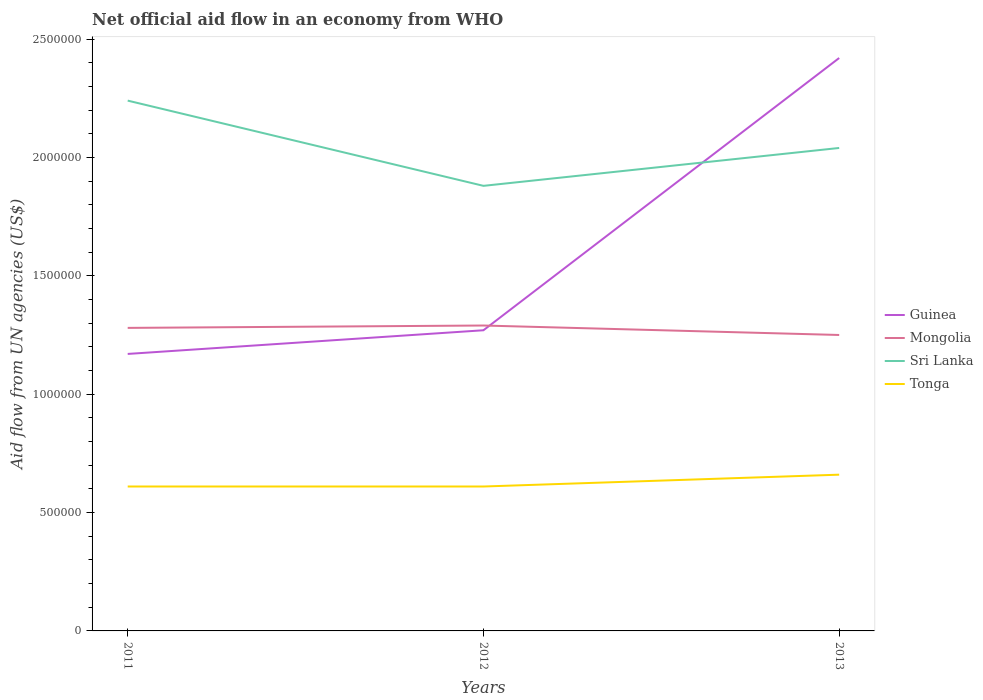How many different coloured lines are there?
Your answer should be very brief. 4. Does the line corresponding to Tonga intersect with the line corresponding to Guinea?
Give a very brief answer. No. Is the number of lines equal to the number of legend labels?
Your answer should be very brief. Yes. Across all years, what is the maximum net official aid flow in Sri Lanka?
Your answer should be compact. 1.88e+06. In which year was the net official aid flow in Guinea maximum?
Ensure brevity in your answer.  2011. What is the total net official aid flow in Sri Lanka in the graph?
Your answer should be very brief. 2.00e+05. What is the difference between the highest and the lowest net official aid flow in Mongolia?
Keep it short and to the point. 2. Is the net official aid flow in Mongolia strictly greater than the net official aid flow in Tonga over the years?
Provide a succinct answer. No. How many lines are there?
Ensure brevity in your answer.  4. How are the legend labels stacked?
Your answer should be compact. Vertical. What is the title of the graph?
Keep it short and to the point. Net official aid flow in an economy from WHO. What is the label or title of the X-axis?
Your answer should be very brief. Years. What is the label or title of the Y-axis?
Provide a short and direct response. Aid flow from UN agencies (US$). What is the Aid flow from UN agencies (US$) of Guinea in 2011?
Offer a very short reply. 1.17e+06. What is the Aid flow from UN agencies (US$) in Mongolia in 2011?
Offer a very short reply. 1.28e+06. What is the Aid flow from UN agencies (US$) of Sri Lanka in 2011?
Ensure brevity in your answer.  2.24e+06. What is the Aid flow from UN agencies (US$) of Tonga in 2011?
Provide a short and direct response. 6.10e+05. What is the Aid flow from UN agencies (US$) of Guinea in 2012?
Offer a very short reply. 1.27e+06. What is the Aid flow from UN agencies (US$) in Mongolia in 2012?
Your answer should be very brief. 1.29e+06. What is the Aid flow from UN agencies (US$) in Sri Lanka in 2012?
Your answer should be very brief. 1.88e+06. What is the Aid flow from UN agencies (US$) of Tonga in 2012?
Provide a succinct answer. 6.10e+05. What is the Aid flow from UN agencies (US$) of Guinea in 2013?
Your answer should be compact. 2.42e+06. What is the Aid flow from UN agencies (US$) of Mongolia in 2013?
Give a very brief answer. 1.25e+06. What is the Aid flow from UN agencies (US$) of Sri Lanka in 2013?
Ensure brevity in your answer.  2.04e+06. Across all years, what is the maximum Aid flow from UN agencies (US$) of Guinea?
Your answer should be compact. 2.42e+06. Across all years, what is the maximum Aid flow from UN agencies (US$) in Mongolia?
Offer a very short reply. 1.29e+06. Across all years, what is the maximum Aid flow from UN agencies (US$) in Sri Lanka?
Ensure brevity in your answer.  2.24e+06. Across all years, what is the maximum Aid flow from UN agencies (US$) of Tonga?
Keep it short and to the point. 6.60e+05. Across all years, what is the minimum Aid flow from UN agencies (US$) of Guinea?
Make the answer very short. 1.17e+06. Across all years, what is the minimum Aid flow from UN agencies (US$) in Mongolia?
Give a very brief answer. 1.25e+06. Across all years, what is the minimum Aid flow from UN agencies (US$) of Sri Lanka?
Keep it short and to the point. 1.88e+06. Across all years, what is the minimum Aid flow from UN agencies (US$) of Tonga?
Make the answer very short. 6.10e+05. What is the total Aid flow from UN agencies (US$) in Guinea in the graph?
Provide a short and direct response. 4.86e+06. What is the total Aid flow from UN agencies (US$) in Mongolia in the graph?
Make the answer very short. 3.82e+06. What is the total Aid flow from UN agencies (US$) in Sri Lanka in the graph?
Keep it short and to the point. 6.16e+06. What is the total Aid flow from UN agencies (US$) of Tonga in the graph?
Give a very brief answer. 1.88e+06. What is the difference between the Aid flow from UN agencies (US$) in Sri Lanka in 2011 and that in 2012?
Your response must be concise. 3.60e+05. What is the difference between the Aid flow from UN agencies (US$) of Guinea in 2011 and that in 2013?
Ensure brevity in your answer.  -1.25e+06. What is the difference between the Aid flow from UN agencies (US$) in Tonga in 2011 and that in 2013?
Your response must be concise. -5.00e+04. What is the difference between the Aid flow from UN agencies (US$) in Guinea in 2012 and that in 2013?
Keep it short and to the point. -1.15e+06. What is the difference between the Aid flow from UN agencies (US$) in Sri Lanka in 2012 and that in 2013?
Make the answer very short. -1.60e+05. What is the difference between the Aid flow from UN agencies (US$) in Guinea in 2011 and the Aid flow from UN agencies (US$) in Sri Lanka in 2012?
Your answer should be compact. -7.10e+05. What is the difference between the Aid flow from UN agencies (US$) in Guinea in 2011 and the Aid flow from UN agencies (US$) in Tonga in 2012?
Your answer should be compact. 5.60e+05. What is the difference between the Aid flow from UN agencies (US$) in Mongolia in 2011 and the Aid flow from UN agencies (US$) in Sri Lanka in 2012?
Your answer should be compact. -6.00e+05. What is the difference between the Aid flow from UN agencies (US$) in Mongolia in 2011 and the Aid flow from UN agencies (US$) in Tonga in 2012?
Your response must be concise. 6.70e+05. What is the difference between the Aid flow from UN agencies (US$) in Sri Lanka in 2011 and the Aid flow from UN agencies (US$) in Tonga in 2012?
Make the answer very short. 1.63e+06. What is the difference between the Aid flow from UN agencies (US$) of Guinea in 2011 and the Aid flow from UN agencies (US$) of Sri Lanka in 2013?
Keep it short and to the point. -8.70e+05. What is the difference between the Aid flow from UN agencies (US$) of Guinea in 2011 and the Aid flow from UN agencies (US$) of Tonga in 2013?
Offer a terse response. 5.10e+05. What is the difference between the Aid flow from UN agencies (US$) of Mongolia in 2011 and the Aid flow from UN agencies (US$) of Sri Lanka in 2013?
Provide a short and direct response. -7.60e+05. What is the difference between the Aid flow from UN agencies (US$) in Mongolia in 2011 and the Aid flow from UN agencies (US$) in Tonga in 2013?
Offer a terse response. 6.20e+05. What is the difference between the Aid flow from UN agencies (US$) of Sri Lanka in 2011 and the Aid flow from UN agencies (US$) of Tonga in 2013?
Offer a terse response. 1.58e+06. What is the difference between the Aid flow from UN agencies (US$) of Guinea in 2012 and the Aid flow from UN agencies (US$) of Mongolia in 2013?
Keep it short and to the point. 2.00e+04. What is the difference between the Aid flow from UN agencies (US$) of Guinea in 2012 and the Aid flow from UN agencies (US$) of Sri Lanka in 2013?
Ensure brevity in your answer.  -7.70e+05. What is the difference between the Aid flow from UN agencies (US$) in Mongolia in 2012 and the Aid flow from UN agencies (US$) in Sri Lanka in 2013?
Provide a short and direct response. -7.50e+05. What is the difference between the Aid flow from UN agencies (US$) of Mongolia in 2012 and the Aid flow from UN agencies (US$) of Tonga in 2013?
Offer a terse response. 6.30e+05. What is the difference between the Aid flow from UN agencies (US$) in Sri Lanka in 2012 and the Aid flow from UN agencies (US$) in Tonga in 2013?
Your answer should be very brief. 1.22e+06. What is the average Aid flow from UN agencies (US$) in Guinea per year?
Keep it short and to the point. 1.62e+06. What is the average Aid flow from UN agencies (US$) in Mongolia per year?
Offer a terse response. 1.27e+06. What is the average Aid flow from UN agencies (US$) of Sri Lanka per year?
Keep it short and to the point. 2.05e+06. What is the average Aid flow from UN agencies (US$) of Tonga per year?
Your answer should be very brief. 6.27e+05. In the year 2011, what is the difference between the Aid flow from UN agencies (US$) in Guinea and Aid flow from UN agencies (US$) in Sri Lanka?
Your answer should be very brief. -1.07e+06. In the year 2011, what is the difference between the Aid flow from UN agencies (US$) in Guinea and Aid flow from UN agencies (US$) in Tonga?
Provide a succinct answer. 5.60e+05. In the year 2011, what is the difference between the Aid flow from UN agencies (US$) of Mongolia and Aid flow from UN agencies (US$) of Sri Lanka?
Offer a terse response. -9.60e+05. In the year 2011, what is the difference between the Aid flow from UN agencies (US$) in Mongolia and Aid flow from UN agencies (US$) in Tonga?
Provide a short and direct response. 6.70e+05. In the year 2011, what is the difference between the Aid flow from UN agencies (US$) of Sri Lanka and Aid flow from UN agencies (US$) of Tonga?
Give a very brief answer. 1.63e+06. In the year 2012, what is the difference between the Aid flow from UN agencies (US$) in Guinea and Aid flow from UN agencies (US$) in Sri Lanka?
Ensure brevity in your answer.  -6.10e+05. In the year 2012, what is the difference between the Aid flow from UN agencies (US$) in Mongolia and Aid flow from UN agencies (US$) in Sri Lanka?
Your answer should be very brief. -5.90e+05. In the year 2012, what is the difference between the Aid flow from UN agencies (US$) in Mongolia and Aid flow from UN agencies (US$) in Tonga?
Your response must be concise. 6.80e+05. In the year 2012, what is the difference between the Aid flow from UN agencies (US$) in Sri Lanka and Aid flow from UN agencies (US$) in Tonga?
Your answer should be very brief. 1.27e+06. In the year 2013, what is the difference between the Aid flow from UN agencies (US$) of Guinea and Aid flow from UN agencies (US$) of Mongolia?
Keep it short and to the point. 1.17e+06. In the year 2013, what is the difference between the Aid flow from UN agencies (US$) of Guinea and Aid flow from UN agencies (US$) of Tonga?
Offer a terse response. 1.76e+06. In the year 2013, what is the difference between the Aid flow from UN agencies (US$) in Mongolia and Aid flow from UN agencies (US$) in Sri Lanka?
Make the answer very short. -7.90e+05. In the year 2013, what is the difference between the Aid flow from UN agencies (US$) of Mongolia and Aid flow from UN agencies (US$) of Tonga?
Give a very brief answer. 5.90e+05. In the year 2013, what is the difference between the Aid flow from UN agencies (US$) of Sri Lanka and Aid flow from UN agencies (US$) of Tonga?
Provide a succinct answer. 1.38e+06. What is the ratio of the Aid flow from UN agencies (US$) in Guinea in 2011 to that in 2012?
Give a very brief answer. 0.92. What is the ratio of the Aid flow from UN agencies (US$) of Sri Lanka in 2011 to that in 2012?
Your answer should be very brief. 1.19. What is the ratio of the Aid flow from UN agencies (US$) in Guinea in 2011 to that in 2013?
Provide a short and direct response. 0.48. What is the ratio of the Aid flow from UN agencies (US$) in Sri Lanka in 2011 to that in 2013?
Offer a very short reply. 1.1. What is the ratio of the Aid flow from UN agencies (US$) in Tonga in 2011 to that in 2013?
Provide a succinct answer. 0.92. What is the ratio of the Aid flow from UN agencies (US$) of Guinea in 2012 to that in 2013?
Ensure brevity in your answer.  0.52. What is the ratio of the Aid flow from UN agencies (US$) in Mongolia in 2012 to that in 2013?
Make the answer very short. 1.03. What is the ratio of the Aid flow from UN agencies (US$) of Sri Lanka in 2012 to that in 2013?
Provide a succinct answer. 0.92. What is the ratio of the Aid flow from UN agencies (US$) of Tonga in 2012 to that in 2013?
Offer a terse response. 0.92. What is the difference between the highest and the second highest Aid flow from UN agencies (US$) of Guinea?
Ensure brevity in your answer.  1.15e+06. What is the difference between the highest and the second highest Aid flow from UN agencies (US$) of Sri Lanka?
Offer a terse response. 2.00e+05. What is the difference between the highest and the lowest Aid flow from UN agencies (US$) of Guinea?
Your response must be concise. 1.25e+06. What is the difference between the highest and the lowest Aid flow from UN agencies (US$) of Mongolia?
Offer a terse response. 4.00e+04. What is the difference between the highest and the lowest Aid flow from UN agencies (US$) in Sri Lanka?
Make the answer very short. 3.60e+05. What is the difference between the highest and the lowest Aid flow from UN agencies (US$) of Tonga?
Offer a terse response. 5.00e+04. 